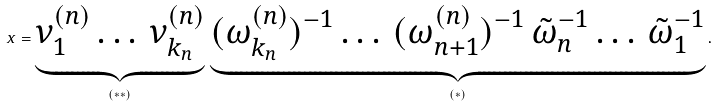<formula> <loc_0><loc_0><loc_500><loc_500>x = \underbrace { \nu _ { 1 } ^ { ( n ) } \dots \, \nu _ { k _ { n } } ^ { ( n ) } } _ { ( * * ) } \, \underbrace { ( \omega _ { k _ { n } } ^ { ( n ) } ) ^ { - 1 } \dots \, ( \omega _ { n + 1 } ^ { ( n ) } ) ^ { - 1 } \, \tilde { \omega } _ { n } ^ { - 1 } \dots \, \tilde { \omega } _ { 1 } ^ { - 1 } } _ { ( * ) } .</formula> 